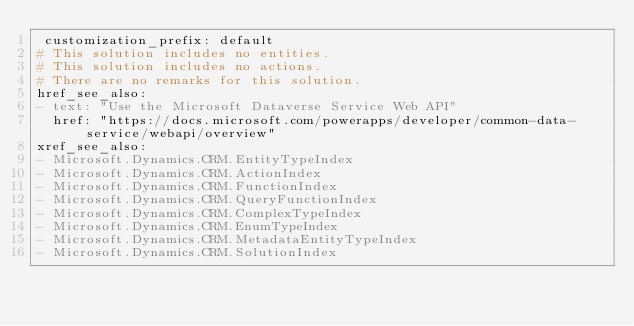Convert code to text. <code><loc_0><loc_0><loc_500><loc_500><_YAML_> customization_prefix: default
# This solution includes no entities.
# This solution includes no actions.
# There are no remarks for this solution.
href_see_also:
- text: "Use the Microsoft Dataverse Service Web API"
  href: "https://docs.microsoft.com/powerapps/developer/common-data-service/webapi/overview"
xref_see_also:
- Microsoft.Dynamics.CRM.EntityTypeIndex
- Microsoft.Dynamics.CRM.ActionIndex
- Microsoft.Dynamics.CRM.FunctionIndex
- Microsoft.Dynamics.CRM.QueryFunctionIndex
- Microsoft.Dynamics.CRM.ComplexTypeIndex
- Microsoft.Dynamics.CRM.EnumTypeIndex
- Microsoft.Dynamics.CRM.MetadataEntityTypeIndex
- Microsoft.Dynamics.CRM.SolutionIndex</code> 